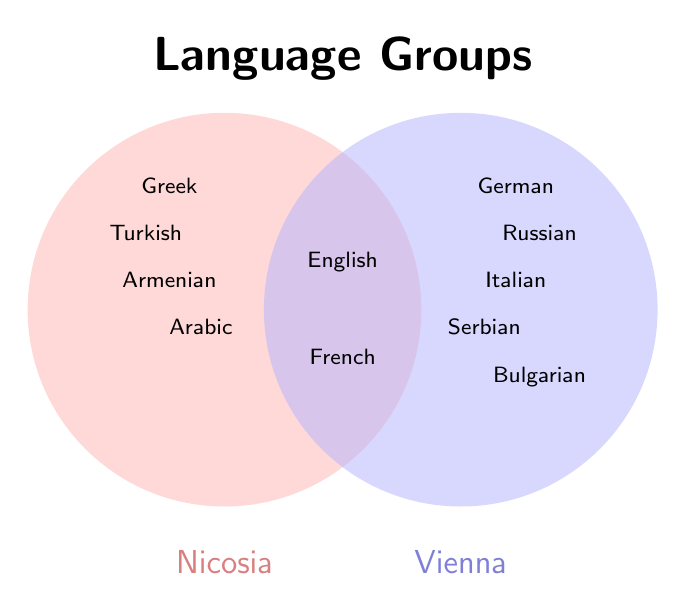What is the main title of the figure? The main title is typically found at the top of the figure, and it describes the overall content of the chart. In this case, it is showing language groups.
Answer: Language Groups Which languages are spoken in both Nicosia and Vienna? The center area of a Venn Diagram represents items that belong to both sets. In this figure, these languages are in the overlapping region.
Answer: English, French List all languages specific to Vienna but not to Nicosia. Languages specific to Vienna are found in the part of the Vienna circle that does not overlap with the Nicosia circle.
Answer: German, Russian, Italian, Serbian, Bulgarian Which languages are unique to Nicosia? Languages unique to Nicosia are within the Nicosia circle but outside the overlapping section with Vienna.
Answer: Greek, Turkish, Armenian, Arabic How many languages are common in both cities? Count the number of items in the overlapping section of the Venn Diagram. The overlapping section includes English and French.
Answer: 2 Which side of the Venn Diagram represents Vienna? The labels below each circle identify which circle represents which data set. The circle labeled "Vienna" is on the right.
Answer: Right Name a language that is spoken only in one of the cities but is not unique there. A language that appears in only one of the circles and outside the overlapping region is unique. Greek, Turkish, Armenian, Arabic, German, Russian, Italian, Serbian, Bulgarian all fit this criteria.
Answer: Russian Compare the number of unique languages in Nicosia to those in Vienna. Count the unique languages in each circle and compare them. Nicosia has 4 unique languages: Greek, Turkish, Armenian, Arabic. Vienna has 5: German, Russian, Italian, Serbian, Bulgarian.
Answer: Vienna has one more unique language than Nicosia Are there more languages spoken in Vienna than in Nicosia, including both shared and unique languages? Count all languages in each circle (combining unique and shared). Nicosia: Greek, Turkish, Armenian, Arabic, English, French = 6. Vienna: German, Russian, Italian, Serbian, Bulgarian, English, French = 7.
Answer: Yes 